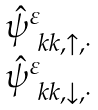Convert formula to latex. <formula><loc_0><loc_0><loc_500><loc_500>\begin{matrix} \hat { \psi } ^ { \varepsilon } _ { \ k k , \uparrow , \cdot } \\ \hat { \psi } ^ { \varepsilon } _ { \ k k , \downarrow , \cdot } \end{matrix}</formula> 